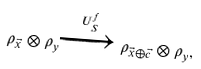<formula> <loc_0><loc_0><loc_500><loc_500>\rho _ { \vec { x } } \otimes \rho _ { y } \xrightarrow { U _ { S } ^ { f } } \rho _ { \vec { x } \oplus \vec { c } } \otimes \rho _ { y } ,</formula> 